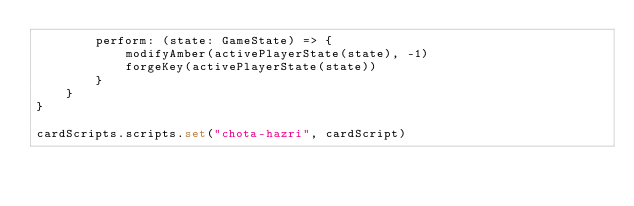<code> <loc_0><loc_0><loc_500><loc_500><_TypeScript_>        perform: (state: GameState) => {
            modifyAmber(activePlayerState(state), -1)
            forgeKey(activePlayerState(state))
        }
    }
}

cardScripts.scripts.set("chota-hazri", cardScript)</code> 